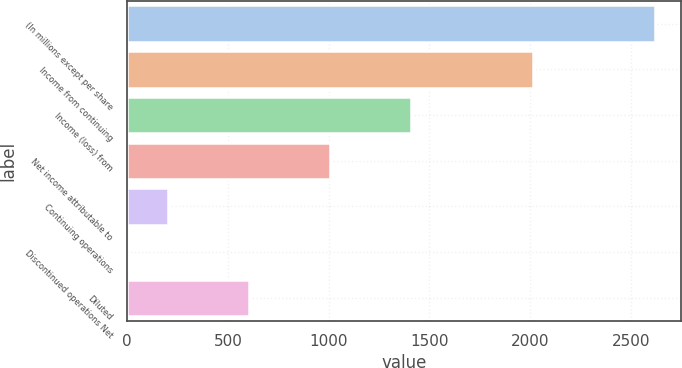<chart> <loc_0><loc_0><loc_500><loc_500><bar_chart><fcel>(In millions except per share<fcel>Income from continuing<fcel>Income (loss) from<fcel>Net income attributable to<fcel>Continuing operations<fcel>Discontinued operations Net<fcel>Diluted<nl><fcel>2619.53<fcel>2015.03<fcel>1410.53<fcel>1007.53<fcel>201.55<fcel>0.05<fcel>604.55<nl></chart> 